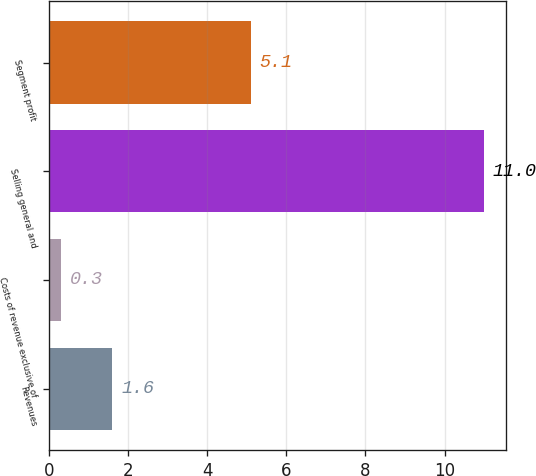<chart> <loc_0><loc_0><loc_500><loc_500><bar_chart><fcel>Revenues<fcel>Costs of revenue exclusive of<fcel>Selling general and<fcel>Segment profit<nl><fcel>1.6<fcel>0.3<fcel>11<fcel>5.1<nl></chart> 